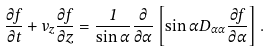Convert formula to latex. <formula><loc_0><loc_0><loc_500><loc_500>\frac { \partial f } { \partial t } + v _ { z } \frac { \partial f } { \partial z } = \frac { 1 } { \sin \alpha } \frac { \partial } { \partial \alpha } \left [ \sin \alpha D _ { \alpha \alpha } \frac { \partial f } { \partial \alpha } \right ] .</formula> 